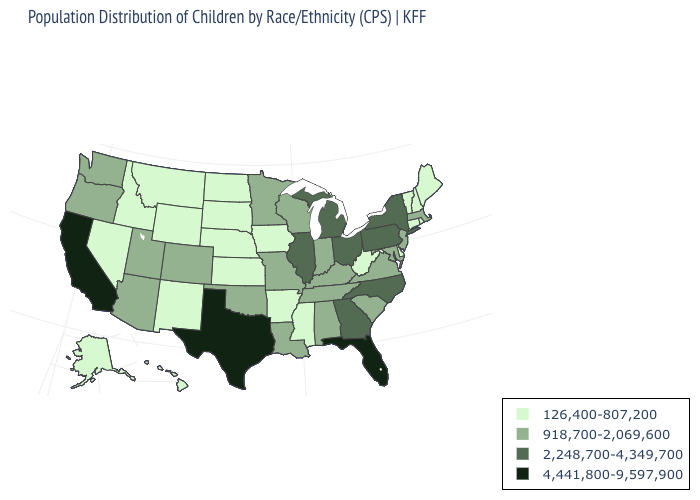What is the value of Maryland?
Quick response, please. 918,700-2,069,600. What is the value of Pennsylvania?
Write a very short answer. 2,248,700-4,349,700. Name the states that have a value in the range 2,248,700-4,349,700?
Short answer required. Georgia, Illinois, Michigan, New York, North Carolina, Ohio, Pennsylvania. What is the highest value in the West ?
Be succinct. 4,441,800-9,597,900. Among the states that border New Hampshire , does Maine have the highest value?
Keep it brief. No. Name the states that have a value in the range 4,441,800-9,597,900?
Keep it brief. California, Florida, Texas. Is the legend a continuous bar?
Keep it brief. No. Does Delaware have the highest value in the USA?
Concise answer only. No. Does Michigan have the same value as Colorado?
Quick response, please. No. Among the states that border Montana , which have the highest value?
Write a very short answer. Idaho, North Dakota, South Dakota, Wyoming. What is the value of Louisiana?
Short answer required. 918,700-2,069,600. What is the value of South Carolina?
Be succinct. 918,700-2,069,600. Does New Hampshire have the highest value in the Northeast?
Write a very short answer. No. Which states have the lowest value in the Northeast?
Keep it brief. Connecticut, Maine, New Hampshire, Rhode Island, Vermont. Name the states that have a value in the range 918,700-2,069,600?
Quick response, please. Alabama, Arizona, Colorado, Indiana, Kentucky, Louisiana, Maryland, Massachusetts, Minnesota, Missouri, New Jersey, Oklahoma, Oregon, South Carolina, Tennessee, Utah, Virginia, Washington, Wisconsin. 